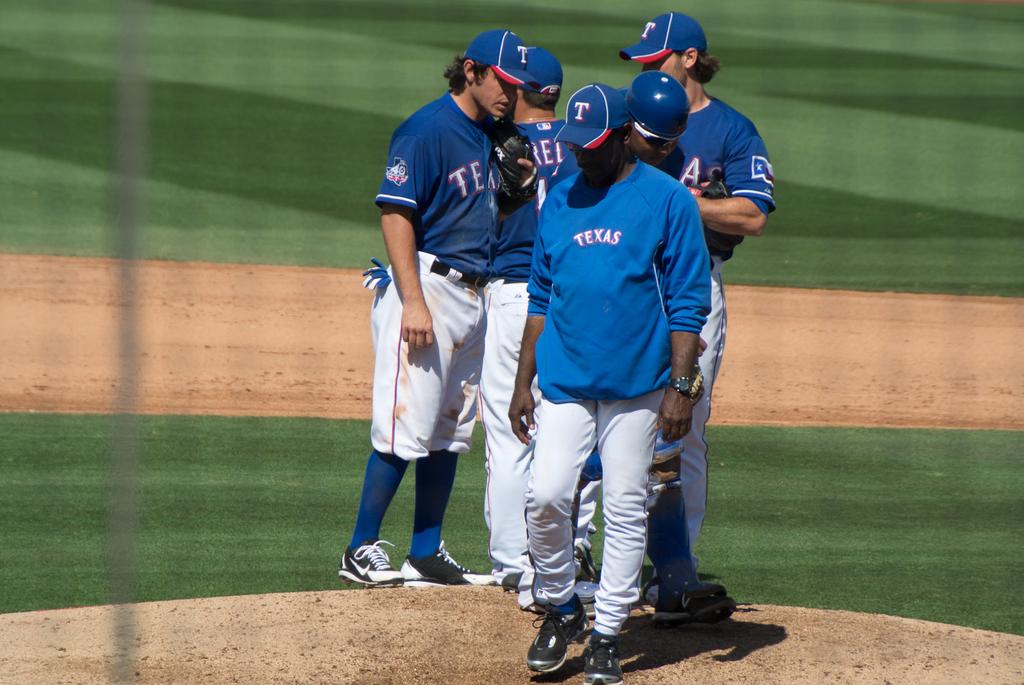Where does this team play?
Provide a succinct answer. Texas. 